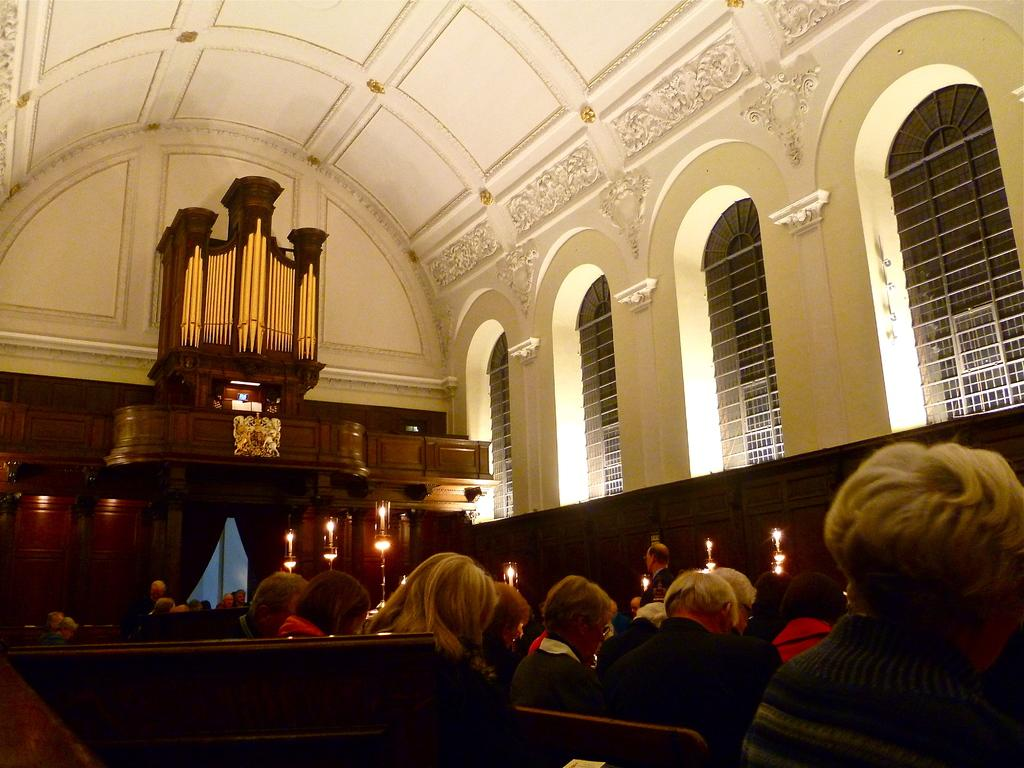What type of building is depicted in the image? The image shows the inside view of a church. What can be observed about the people inside the church? Men and women are sitting in the church. Are there any specific objects or decorations present in the image? Candles are present in front of the sitting area. What color are the walls and roof of the church? The walls and roof of the church are white. What is the average income of the people sitting in the church? There is no information about the income of the people in the image, as it only shows their presence inside the church. 